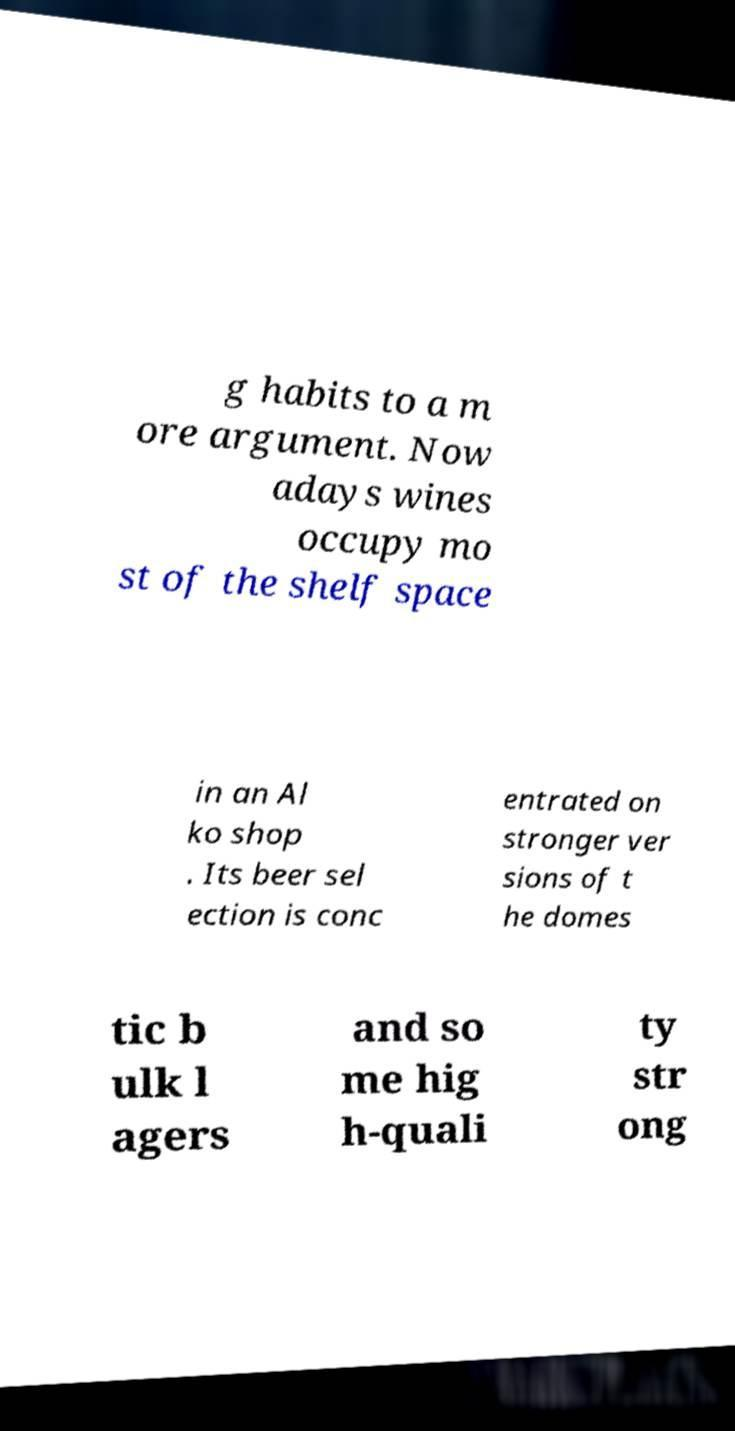What messages or text are displayed in this image? I need them in a readable, typed format. g habits to a m ore argument. Now adays wines occupy mo st of the shelf space in an Al ko shop . Its beer sel ection is conc entrated on stronger ver sions of t he domes tic b ulk l agers and so me hig h-quali ty str ong 